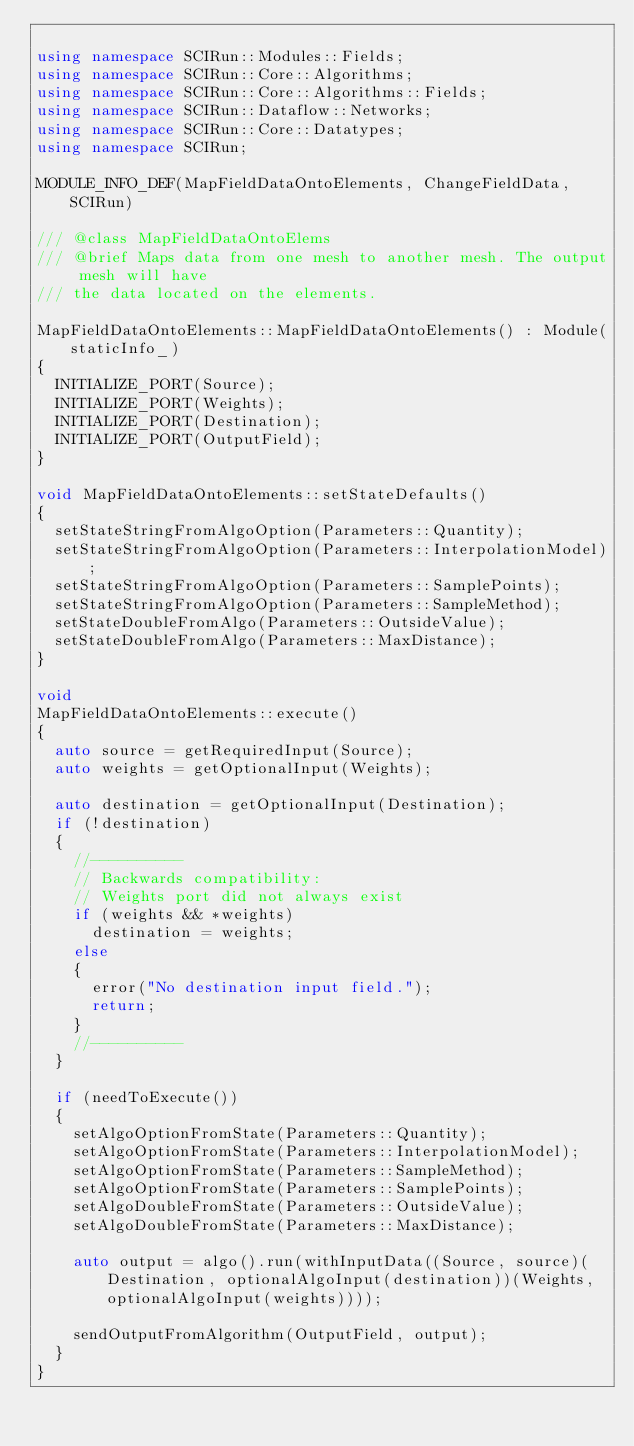<code> <loc_0><loc_0><loc_500><loc_500><_C++_>
using namespace SCIRun::Modules::Fields;
using namespace SCIRun::Core::Algorithms;
using namespace SCIRun::Core::Algorithms::Fields;
using namespace SCIRun::Dataflow::Networks;
using namespace SCIRun::Core::Datatypes;
using namespace SCIRun;

MODULE_INFO_DEF(MapFieldDataOntoElements, ChangeFieldData, SCIRun)

/// @class MapFieldDataOntoElems
/// @brief Maps data from one mesh to another mesh. The output mesh will have
/// the data located on the elements.

MapFieldDataOntoElements::MapFieldDataOntoElements() : Module(staticInfo_)
{
  INITIALIZE_PORT(Source);
  INITIALIZE_PORT(Weights);
  INITIALIZE_PORT(Destination);
  INITIALIZE_PORT(OutputField);
}

void MapFieldDataOntoElements::setStateDefaults()
{
  setStateStringFromAlgoOption(Parameters::Quantity);
  setStateStringFromAlgoOption(Parameters::InterpolationModel);
  setStateStringFromAlgoOption(Parameters::SamplePoints);
  setStateStringFromAlgoOption(Parameters::SampleMethod);
  setStateDoubleFromAlgo(Parameters::OutsideValue);
  setStateDoubleFromAlgo(Parameters::MaxDistance);
}

void
MapFieldDataOntoElements::execute()
{
  auto source = getRequiredInput(Source);
  auto weights = getOptionalInput(Weights);

  auto destination = getOptionalInput(Destination);
  if (!destination)
  {
    //----------
    // Backwards compatibility:
    // Weights port did not always exist
    if (weights && *weights)
      destination = weights;
    else
    {
      error("No destination input field.");
      return;
    }
    //----------
  }

  if (needToExecute())
  {
    setAlgoOptionFromState(Parameters::Quantity);
    setAlgoOptionFromState(Parameters::InterpolationModel);
    setAlgoOptionFromState(Parameters::SampleMethod);
    setAlgoOptionFromState(Parameters::SamplePoints);
    setAlgoDoubleFromState(Parameters::OutsideValue);
    setAlgoDoubleFromState(Parameters::MaxDistance);

    auto output = algo().run(withInputData((Source, source)(Destination, optionalAlgoInput(destination))(Weights, optionalAlgoInput(weights))));

    sendOutputFromAlgorithm(OutputField, output);
  }
}
</code> 